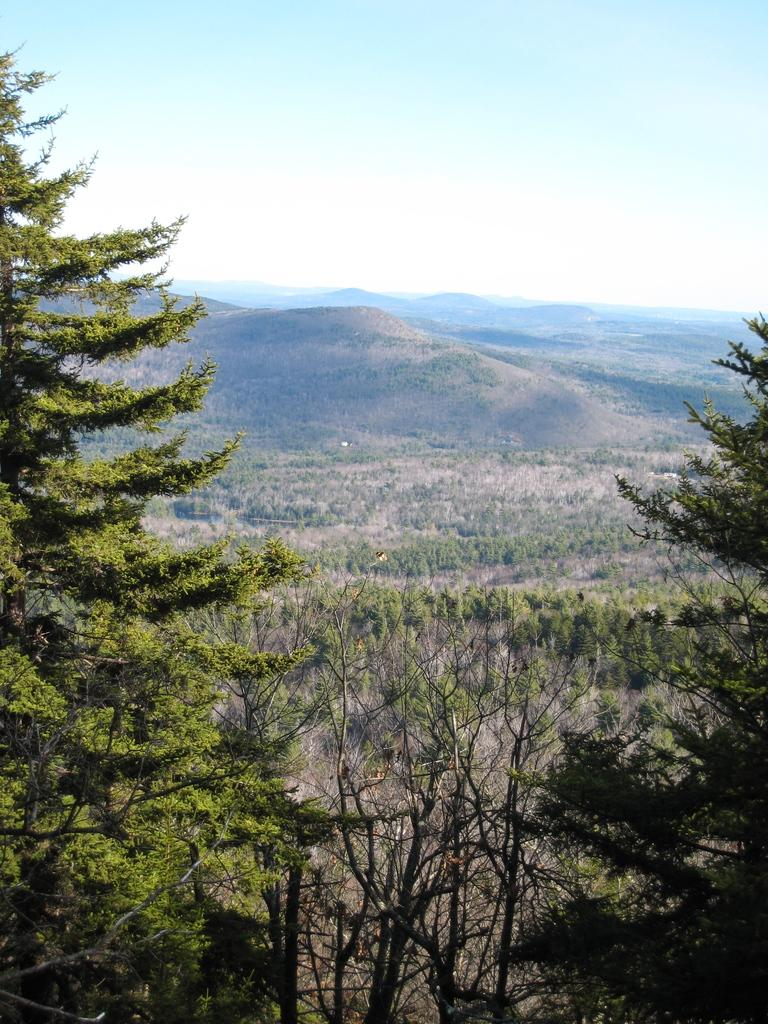What type of vegetation can be seen in the image? There are trees in the image. What can be seen in the distance in the image? There are hills visible in the background of the image. What part of the natural environment is visible in the image? The sky is visible in the image. What type of advertisement can be seen on the trees in the image? There are no advertisements present on the trees in the image. What type of pancake is being served on the yoke in the image? There is no pancake or yoke present in the image. 